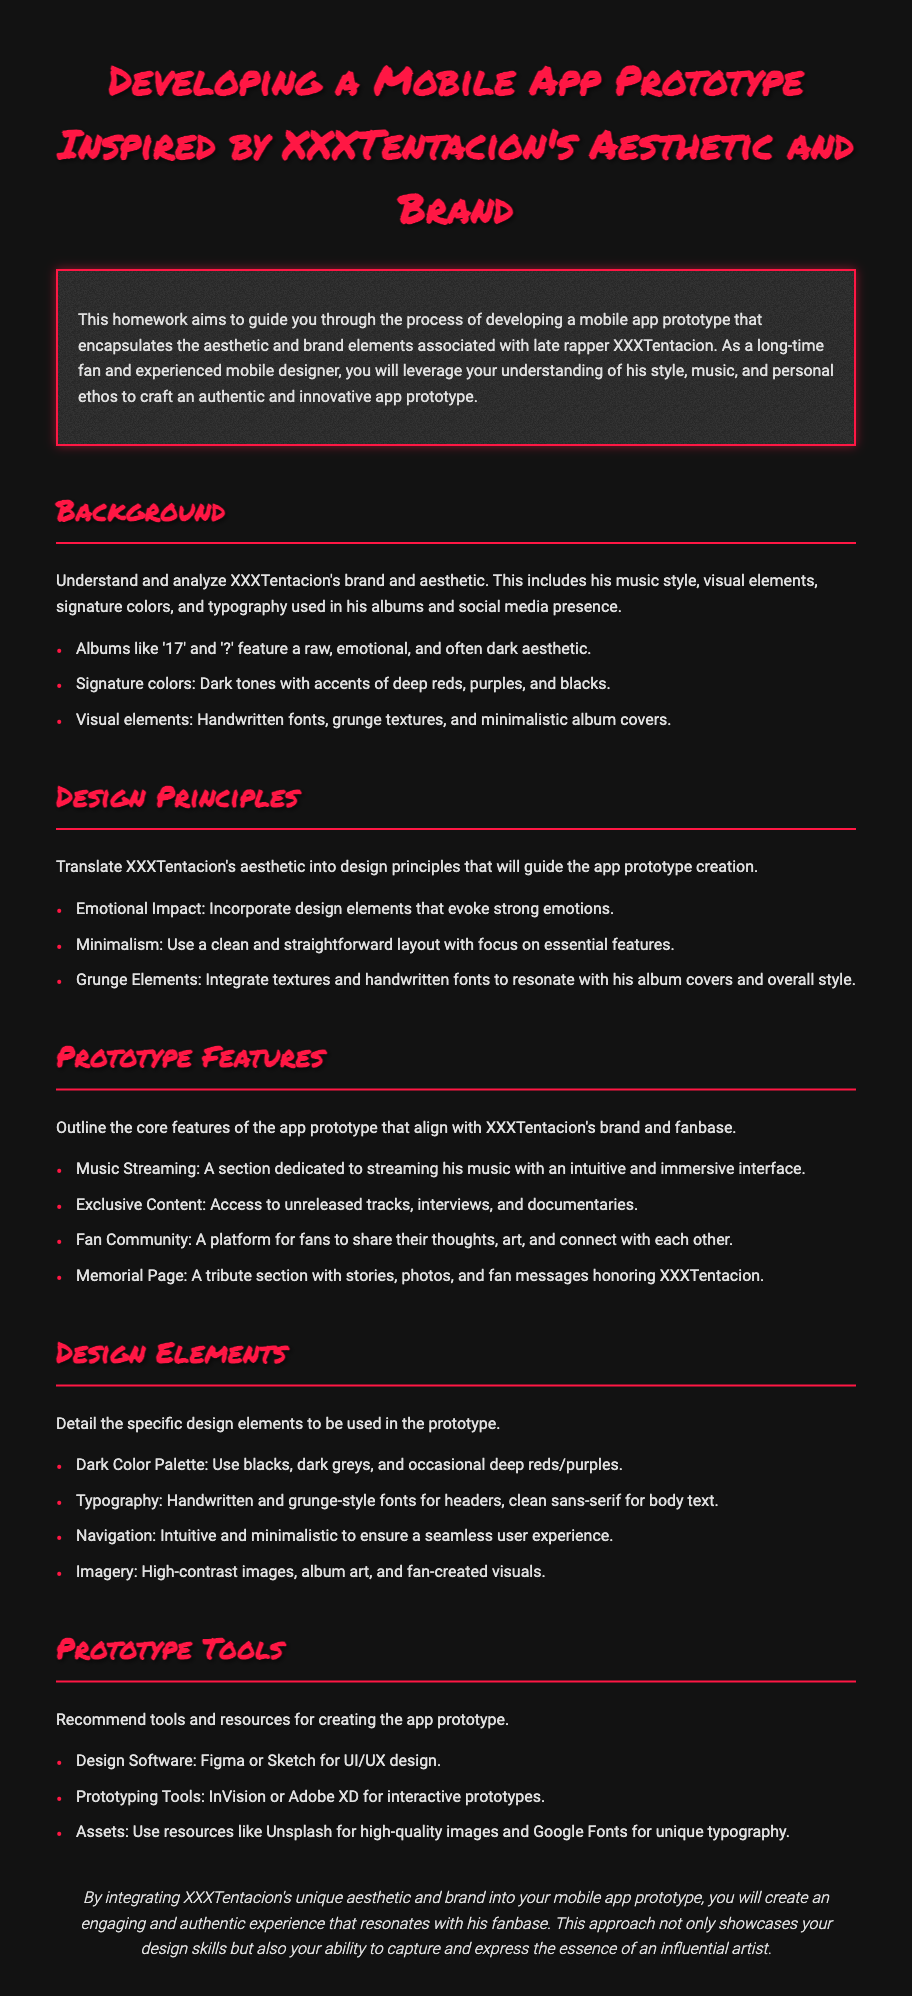What is the title of the homework? The title is presented prominently at the top of the document, indicating the subject matter clearly.
Answer: Developing a Mobile App Prototype Inspired by XXXTentacion's Aesthetic and Brand What are two signature colors associated with XXXTentacion's aesthetic? The document specifies two specific colors that are characteristic of XXXTentacion's brand.
Answer: Deep reds, purples Which design principle emphasizes the incorporation of emotional elements? The concept of evoking strong feelings is highlighted among the design principles in the document.
Answer: Emotional Impact What is one core feature of the app prototype? The document outlines several features, and this question refers to a specific one.
Answer: Music Streaming What design software is recommended for UI/UX design? The document mentions specific software tools that could aid in the design process, including one for UI/UX.
Answer: Figma What type of imagery is suggested for use in the prototype? The document details specific types of images that align with the aesthetic discussed.
Answer: High-contrast images What is the conclusion of the homework document focused on? The document summarizes the main achievement to be accomplished through the app prototype development in its conclusion.
Answer: Engaging and authentic experience What design element involves using a clean sans-serif font in the app? The document outlines different typography styles to be employed, including the type specified in this question.
Answer: Body text 